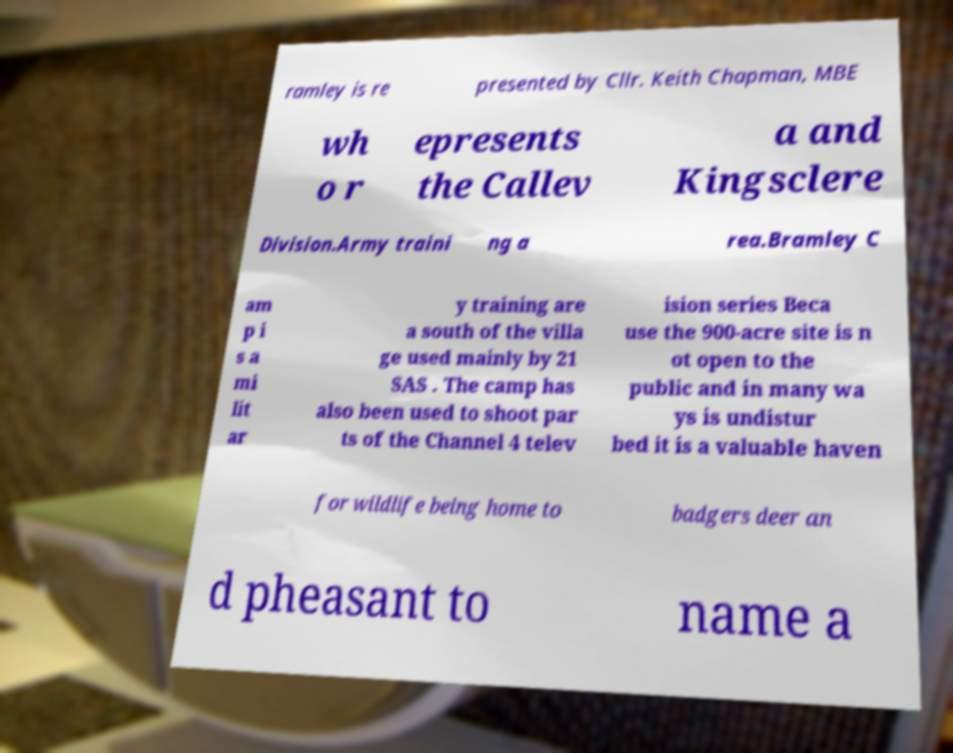Could you extract and type out the text from this image? ramley is re presented by Cllr. Keith Chapman, MBE wh o r epresents the Callev a and Kingsclere Division.Army traini ng a rea.Bramley C am p i s a mi lit ar y training are a south of the villa ge used mainly by 21 SAS . The camp has also been used to shoot par ts of the Channel 4 telev ision series Beca use the 900-acre site is n ot open to the public and in many wa ys is undistur bed it is a valuable haven for wildlife being home to badgers deer an d pheasant to name a 